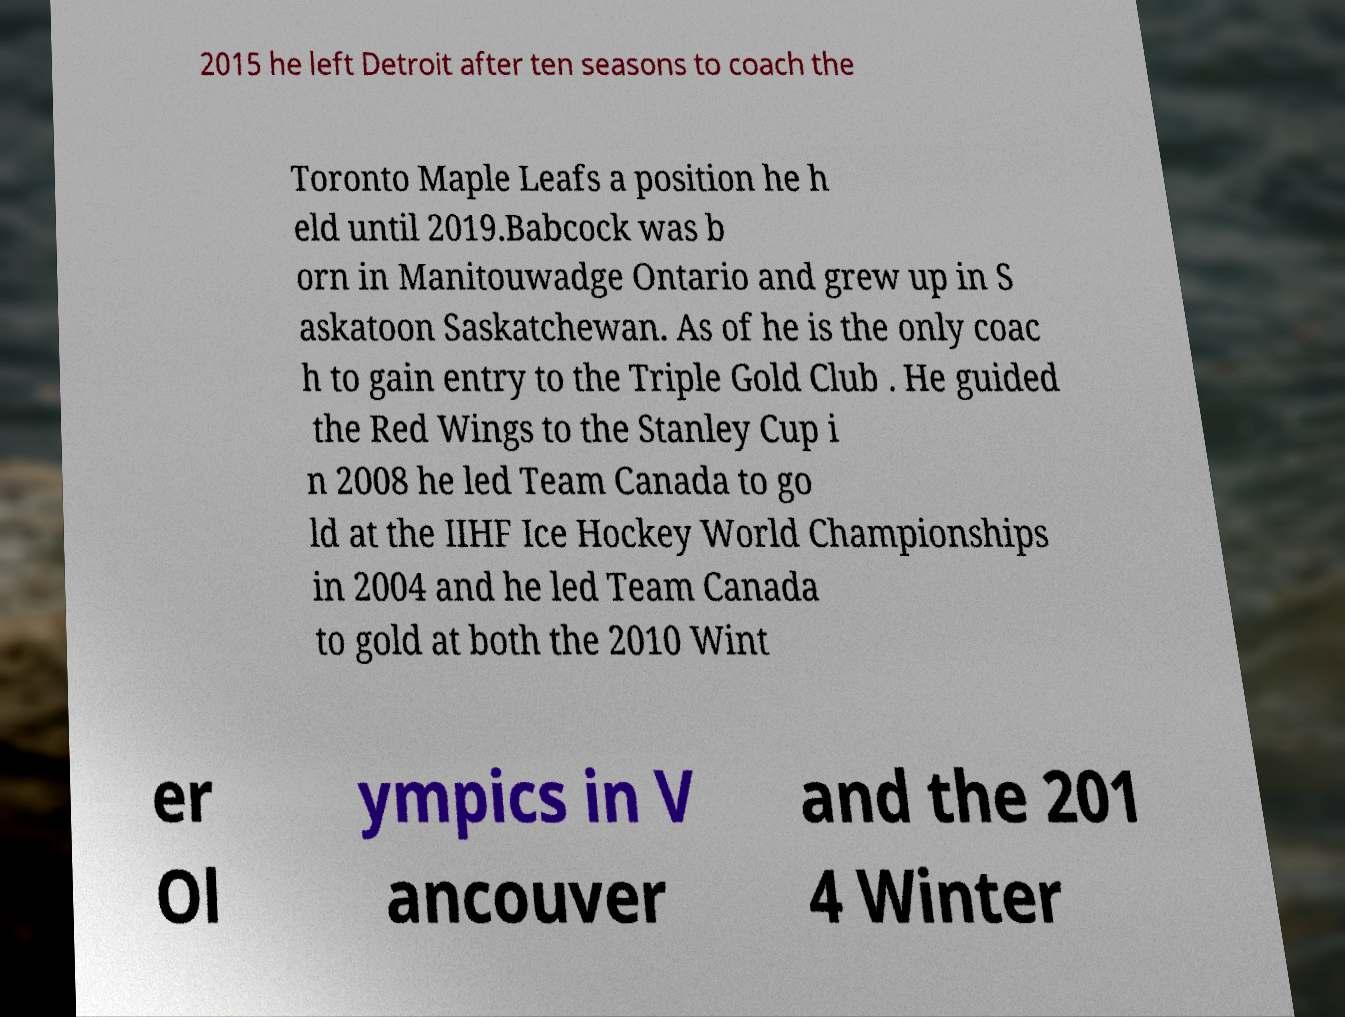Please read and relay the text visible in this image. What does it say? 2015 he left Detroit after ten seasons to coach the Toronto Maple Leafs a position he h eld until 2019.Babcock was b orn in Manitouwadge Ontario and grew up in S askatoon Saskatchewan. As of he is the only coac h to gain entry to the Triple Gold Club . He guided the Red Wings to the Stanley Cup i n 2008 he led Team Canada to go ld at the IIHF Ice Hockey World Championships in 2004 and he led Team Canada to gold at both the 2010 Wint er Ol ympics in V ancouver and the 201 4 Winter 